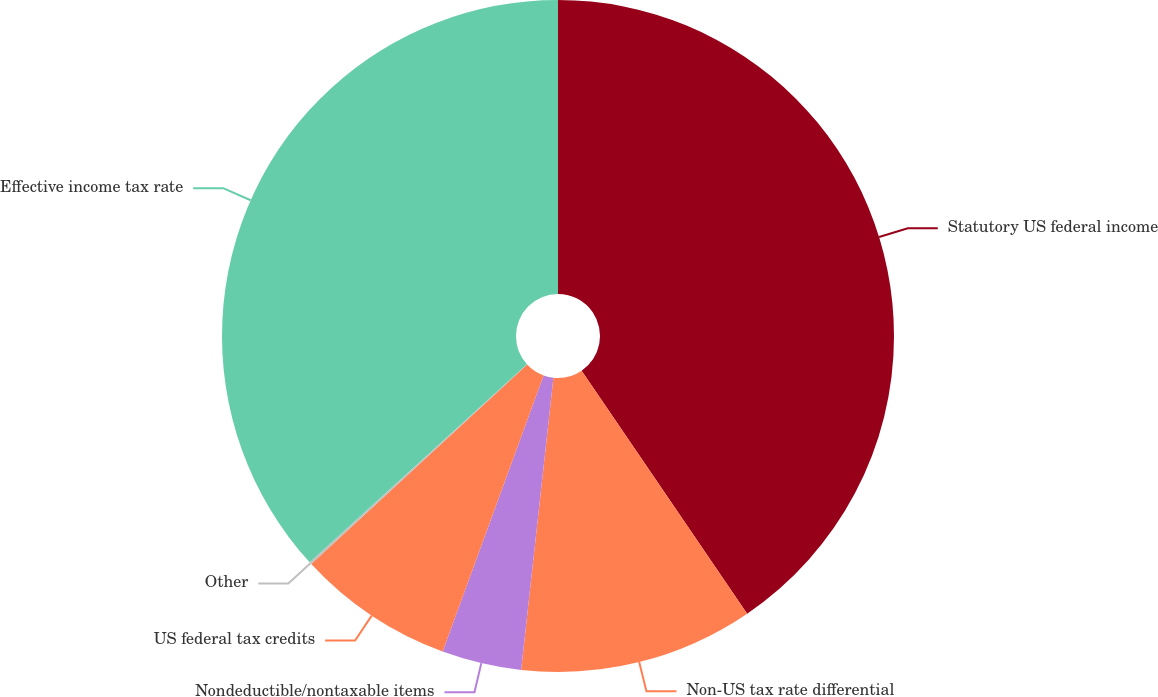Convert chart. <chart><loc_0><loc_0><loc_500><loc_500><pie_chart><fcel>Statutory US federal income<fcel>Non-US tax rate differential<fcel>Nondeductible/nontaxable items<fcel>US federal tax credits<fcel>Other<fcel>Effective income tax rate<nl><fcel>40.49%<fcel>11.27%<fcel>3.83%<fcel>7.55%<fcel>0.11%<fcel>36.77%<nl></chart> 